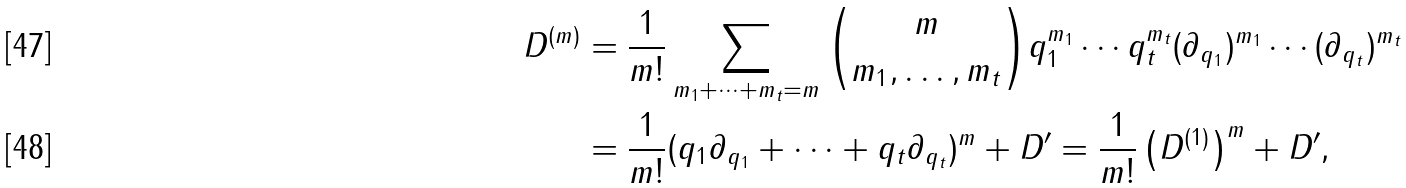<formula> <loc_0><loc_0><loc_500><loc_500>D ^ { ( m ) } & = \frac { 1 } { m ! } \sum _ { m _ { 1 } + \cdots + m _ { t } = m } { m \choose m _ { 1 } , \dots , m _ { t } } q _ { 1 } ^ { m _ { 1 } } \cdots q _ { t } ^ { m _ { t } } ( \partial _ { q _ { 1 } } ) ^ { m _ { 1 } } \cdots ( \partial _ { q _ { t } } ) ^ { m _ { t } } \\ & = \frac { 1 } { m ! } ( q _ { 1 } \partial _ { q _ { 1 } } + \cdots + q _ { t } \partial _ { q _ { t } } ) ^ { m } + D ^ { \prime } = \frac { 1 } { m ! } \left ( D ^ { ( 1 ) } \right ) ^ { m } + D ^ { \prime } ,</formula> 